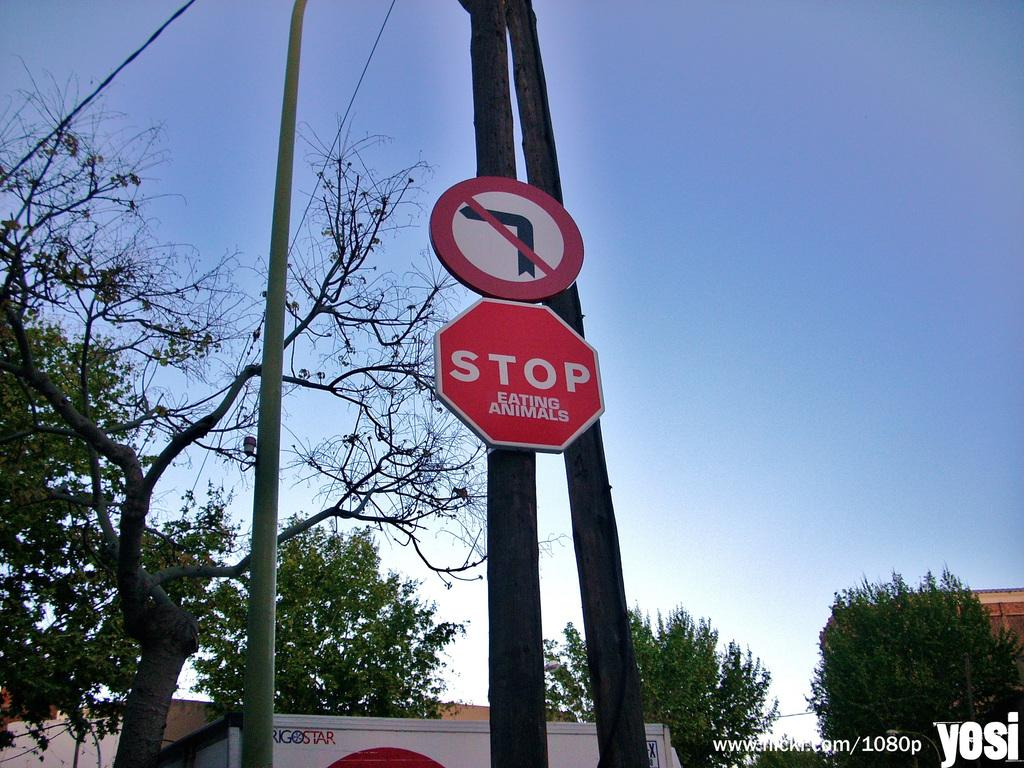<image>
Render a clear and concise summary of the photo. a stop sign that is below a no turn arrow 